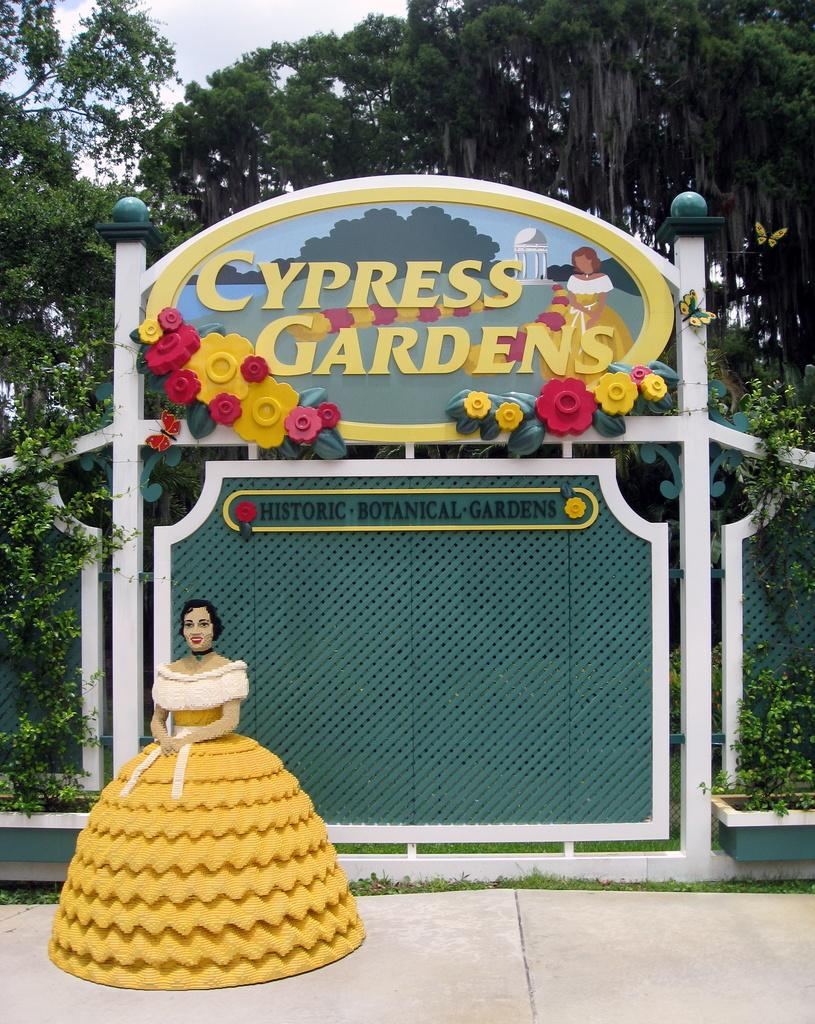What is the main feature of the image? There is a colorful gate in the image. What type of vegetation can be seen in the image? There are green trees in the image. What type of toy is present in the image? There is a yellow and white color toy in the image. What colors are visible in the sky in the image? The sky is in white and blue color. How many houses are visible in the image? There are no houses visible in the image; it primarily features a colorful gate and green trees. What type of linen is draped over the gate in the image? There is no linen present in the image; it only shows a colorful gate and green trees. 